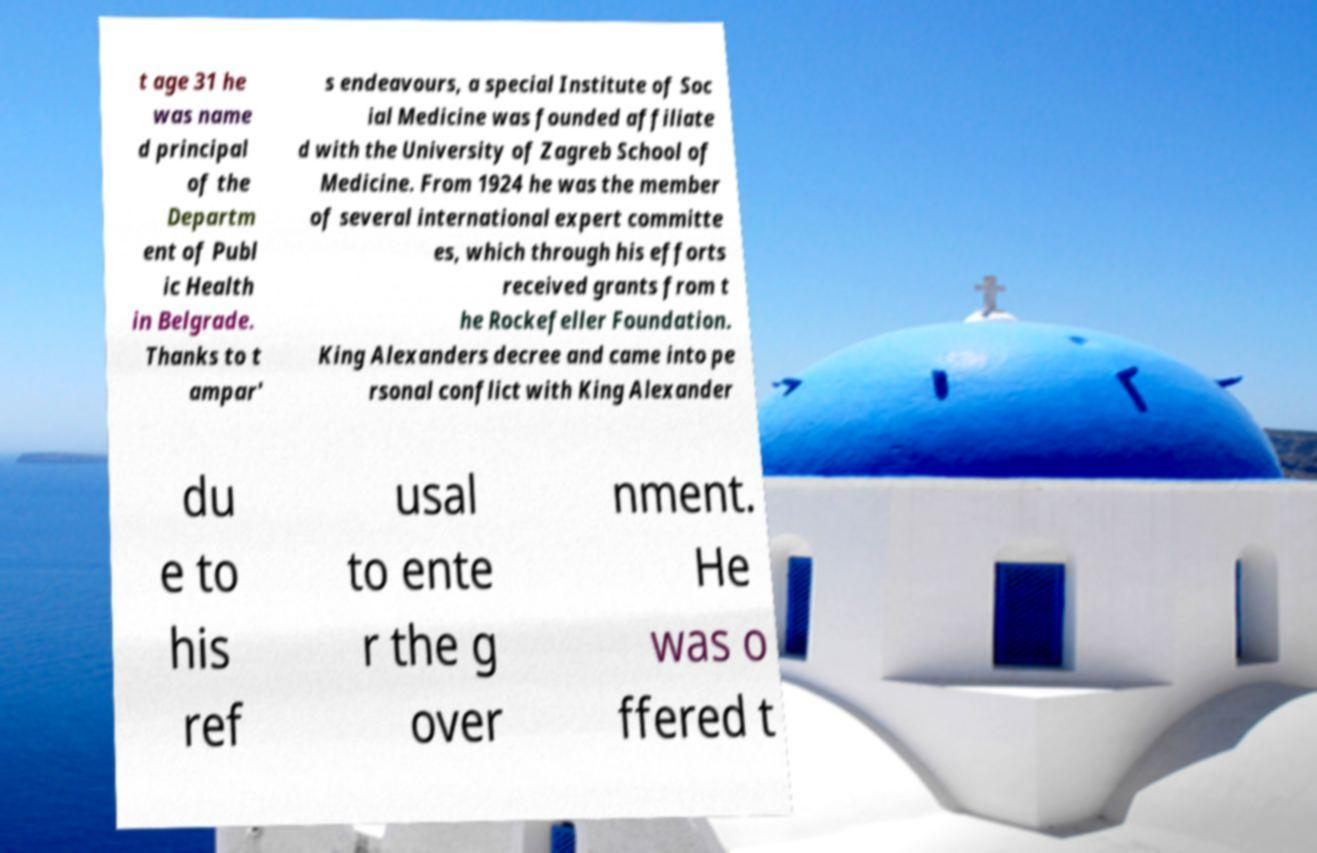For documentation purposes, I need the text within this image transcribed. Could you provide that? t age 31 he was name d principal of the Departm ent of Publ ic Health in Belgrade. Thanks to t ampar' s endeavours, a special Institute of Soc ial Medicine was founded affiliate d with the University of Zagreb School of Medicine. From 1924 he was the member of several international expert committe es, which through his efforts received grants from t he Rockefeller Foundation. King Alexanders decree and came into pe rsonal conflict with King Alexander du e to his ref usal to ente r the g over nment. He was o ffered t 